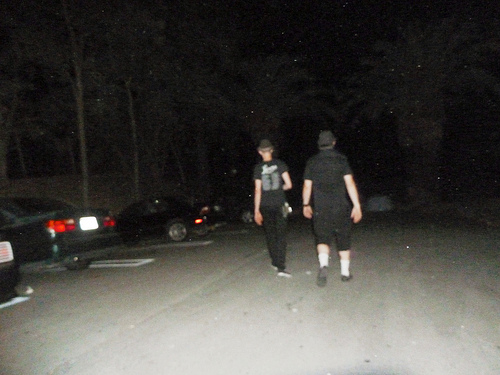<image>
Is the man to the left of the man? No. The man is not to the left of the man. From this viewpoint, they have a different horizontal relationship. 